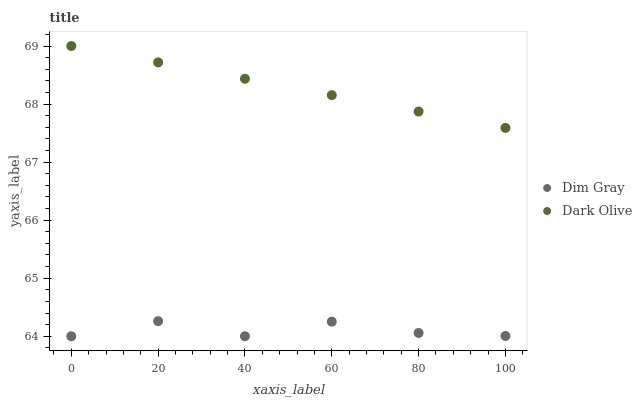Does Dim Gray have the minimum area under the curve?
Answer yes or no. Yes. Does Dark Olive have the maximum area under the curve?
Answer yes or no. Yes. Does Dim Gray have the maximum area under the curve?
Answer yes or no. No. Is Dark Olive the smoothest?
Answer yes or no. Yes. Is Dim Gray the roughest?
Answer yes or no. Yes. Is Dim Gray the smoothest?
Answer yes or no. No. Does Dim Gray have the lowest value?
Answer yes or no. Yes. Does Dark Olive have the highest value?
Answer yes or no. Yes. Does Dim Gray have the highest value?
Answer yes or no. No. Is Dim Gray less than Dark Olive?
Answer yes or no. Yes. Is Dark Olive greater than Dim Gray?
Answer yes or no. Yes. Does Dim Gray intersect Dark Olive?
Answer yes or no. No. 